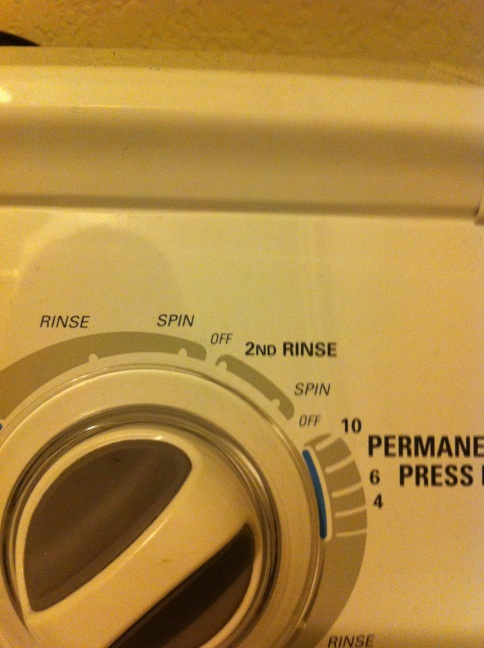What are these arrows on this washer pointing at? Thanks. The arrows on this washer are pointing at various settings for the washing machine. Specifically, they are indicating the options for different cycles such as 'Rinse', 'Spin', 'Off', and '2nd Rinse'. These settings allow you to control how the washing machine will handle the load of laundry. 